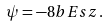Convert formula to latex. <formula><loc_0><loc_0><loc_500><loc_500>\psi = - 8 b E s z \, .</formula> 